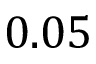<formula> <loc_0><loc_0><loc_500><loc_500>0 . 0 5</formula> 